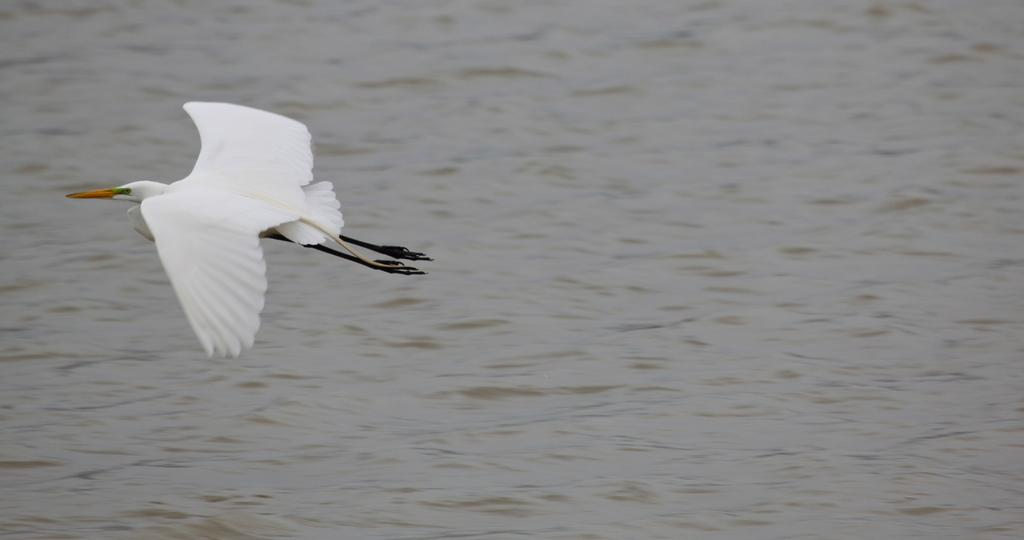What is the main subject of the image? There is a crane in the image. What is the crane doing in the image? The crane is flying in the air. What natural element can be seen in the image? There is water visible in the image. What type of rose is the minister holding in the image? There is no minister or rose present in the image; it features a flying crane and water. 